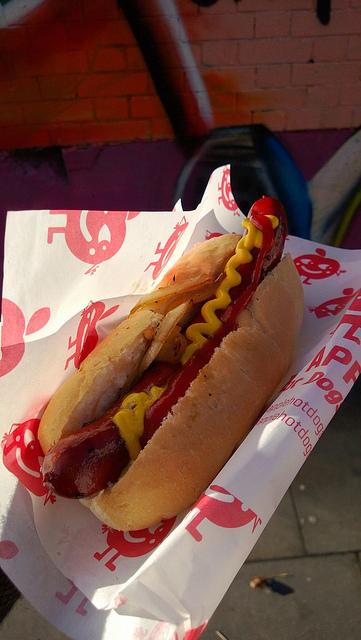Where is this hot dog from?
Write a very short answer. Happy dog. Does the hot dog fit the bun?
Write a very short answer. No. Does this person like ketchup and mustard?
Short answer required. Yes. What sort of food is this?
Write a very short answer. Hot dog. 